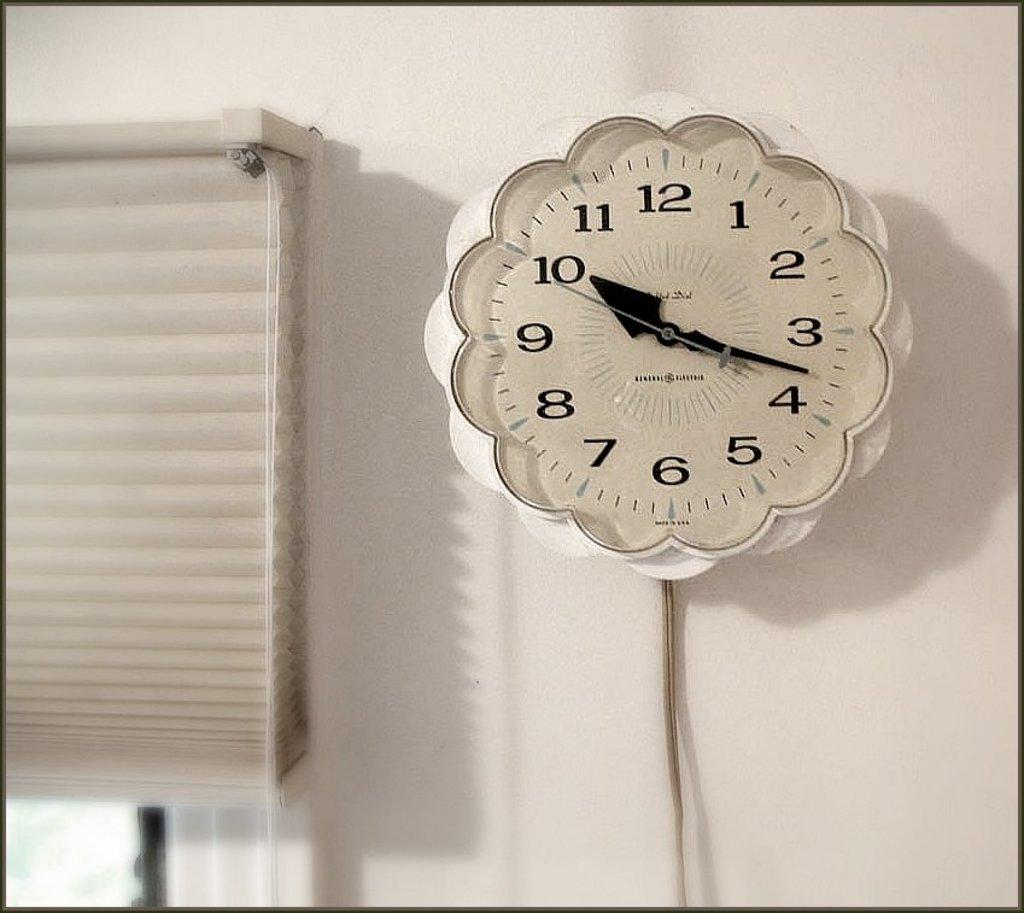Provide a one-sentence caption for the provided image. A scalloped white analog clock with the numbers 1-12 displayed and Made in USA. 